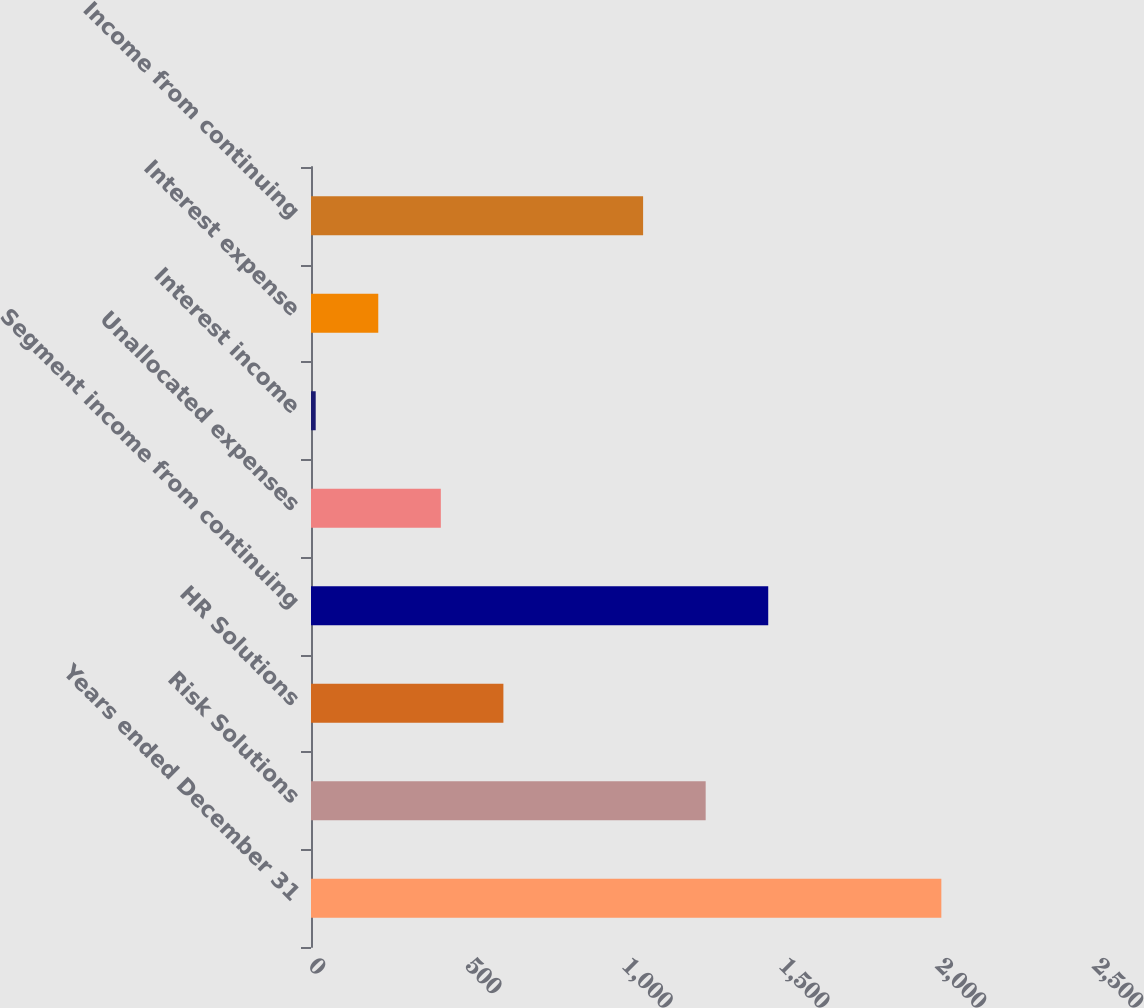Convert chart to OTSL. <chart><loc_0><loc_0><loc_500><loc_500><bar_chart><fcel>Years ended December 31<fcel>Risk Solutions<fcel>HR Solutions<fcel>Segment income from continuing<fcel>Unallocated expenses<fcel>Interest income<fcel>Interest expense<fcel>Income from continuing<nl><fcel>2010<fcel>1258.5<fcel>613.5<fcel>1458<fcel>414<fcel>15<fcel>214.5<fcel>1059<nl></chart> 